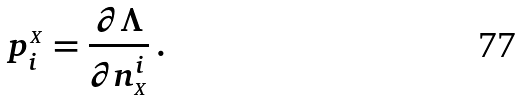Convert formula to latex. <formula><loc_0><loc_0><loc_500><loc_500>p ^ { _ { X } } _ { i } = \frac { \partial \Lambda } { \partial n _ { _ { X } } ^ { i } } \, .</formula> 